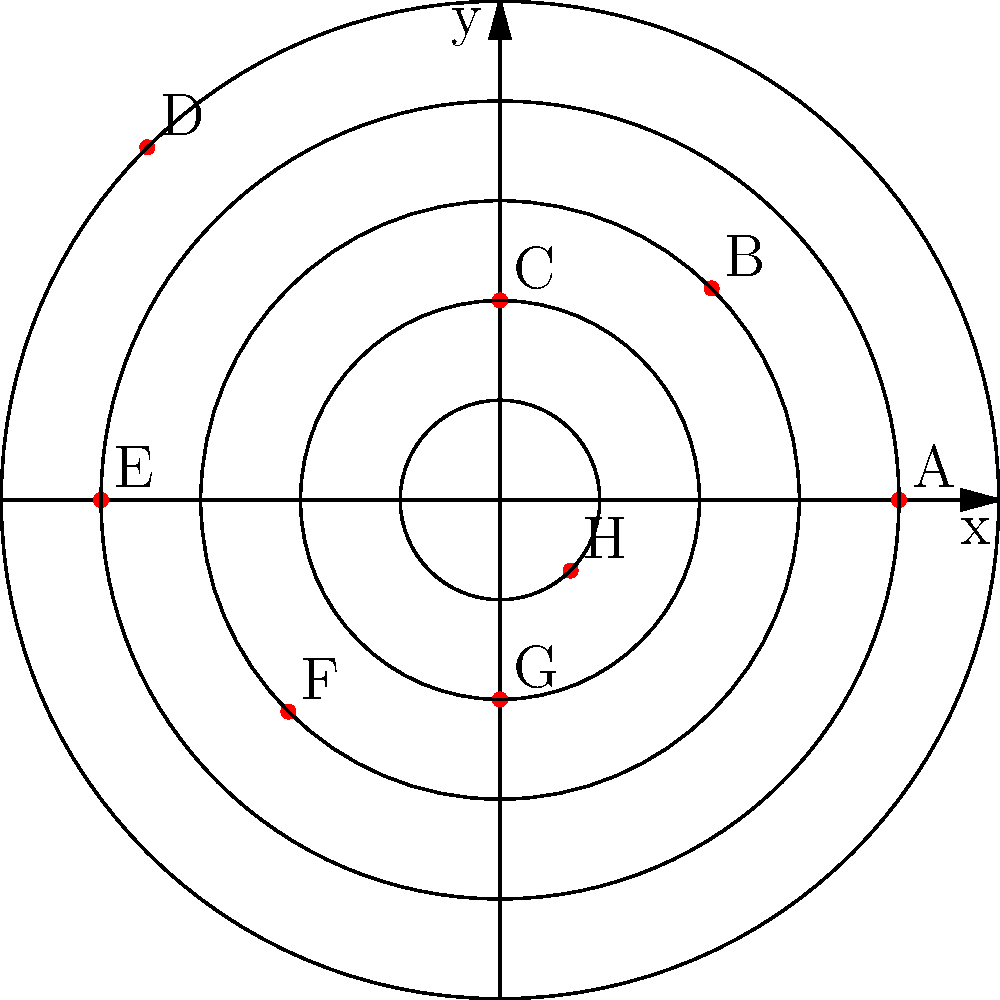Osservando il grafico a coordinate polari che rappresenta l'engagement sui social media per diverse iniziative civiche, quale iniziativa ha ottenuto il maggior livello di engagement? Per determinare quale iniziativa ha ottenuto il maggior livello di engagement, dobbiamo analizzare il grafico a coordinate polari:

1. Nel grafico, ogni punto rappresenta un'iniziativa civica (etichettata da A a H).
2. La distanza dal centro indica il livello di engagement: più lontano è il punto, maggiore è l'engagement.
3. Osserviamo che ci sono 5 cerchi concentrici, che rappresentano diversi livelli di engagement (da 1 a 5).
4. Analizziamo la posizione di ciascun punto:
   - A: sul quarto cerchio (4)
   - B: sul terzo cerchio (3)
   - C: sul secondo cerchio (2)
   - D: sul quinto cerchio (5)
   - E: sul quarto cerchio (4)
   - F: sul terzo cerchio (3)
   - G: sul secondo cerchio (2)
   - H: sul primo cerchio (1)
5. Il punto più lontano dal centro è D, che si trova sul quinto cerchio.

Quindi, l'iniziativa D ha ottenuto il maggior livello di engagement tra tutte le iniziative rappresentate.
Answer: D 